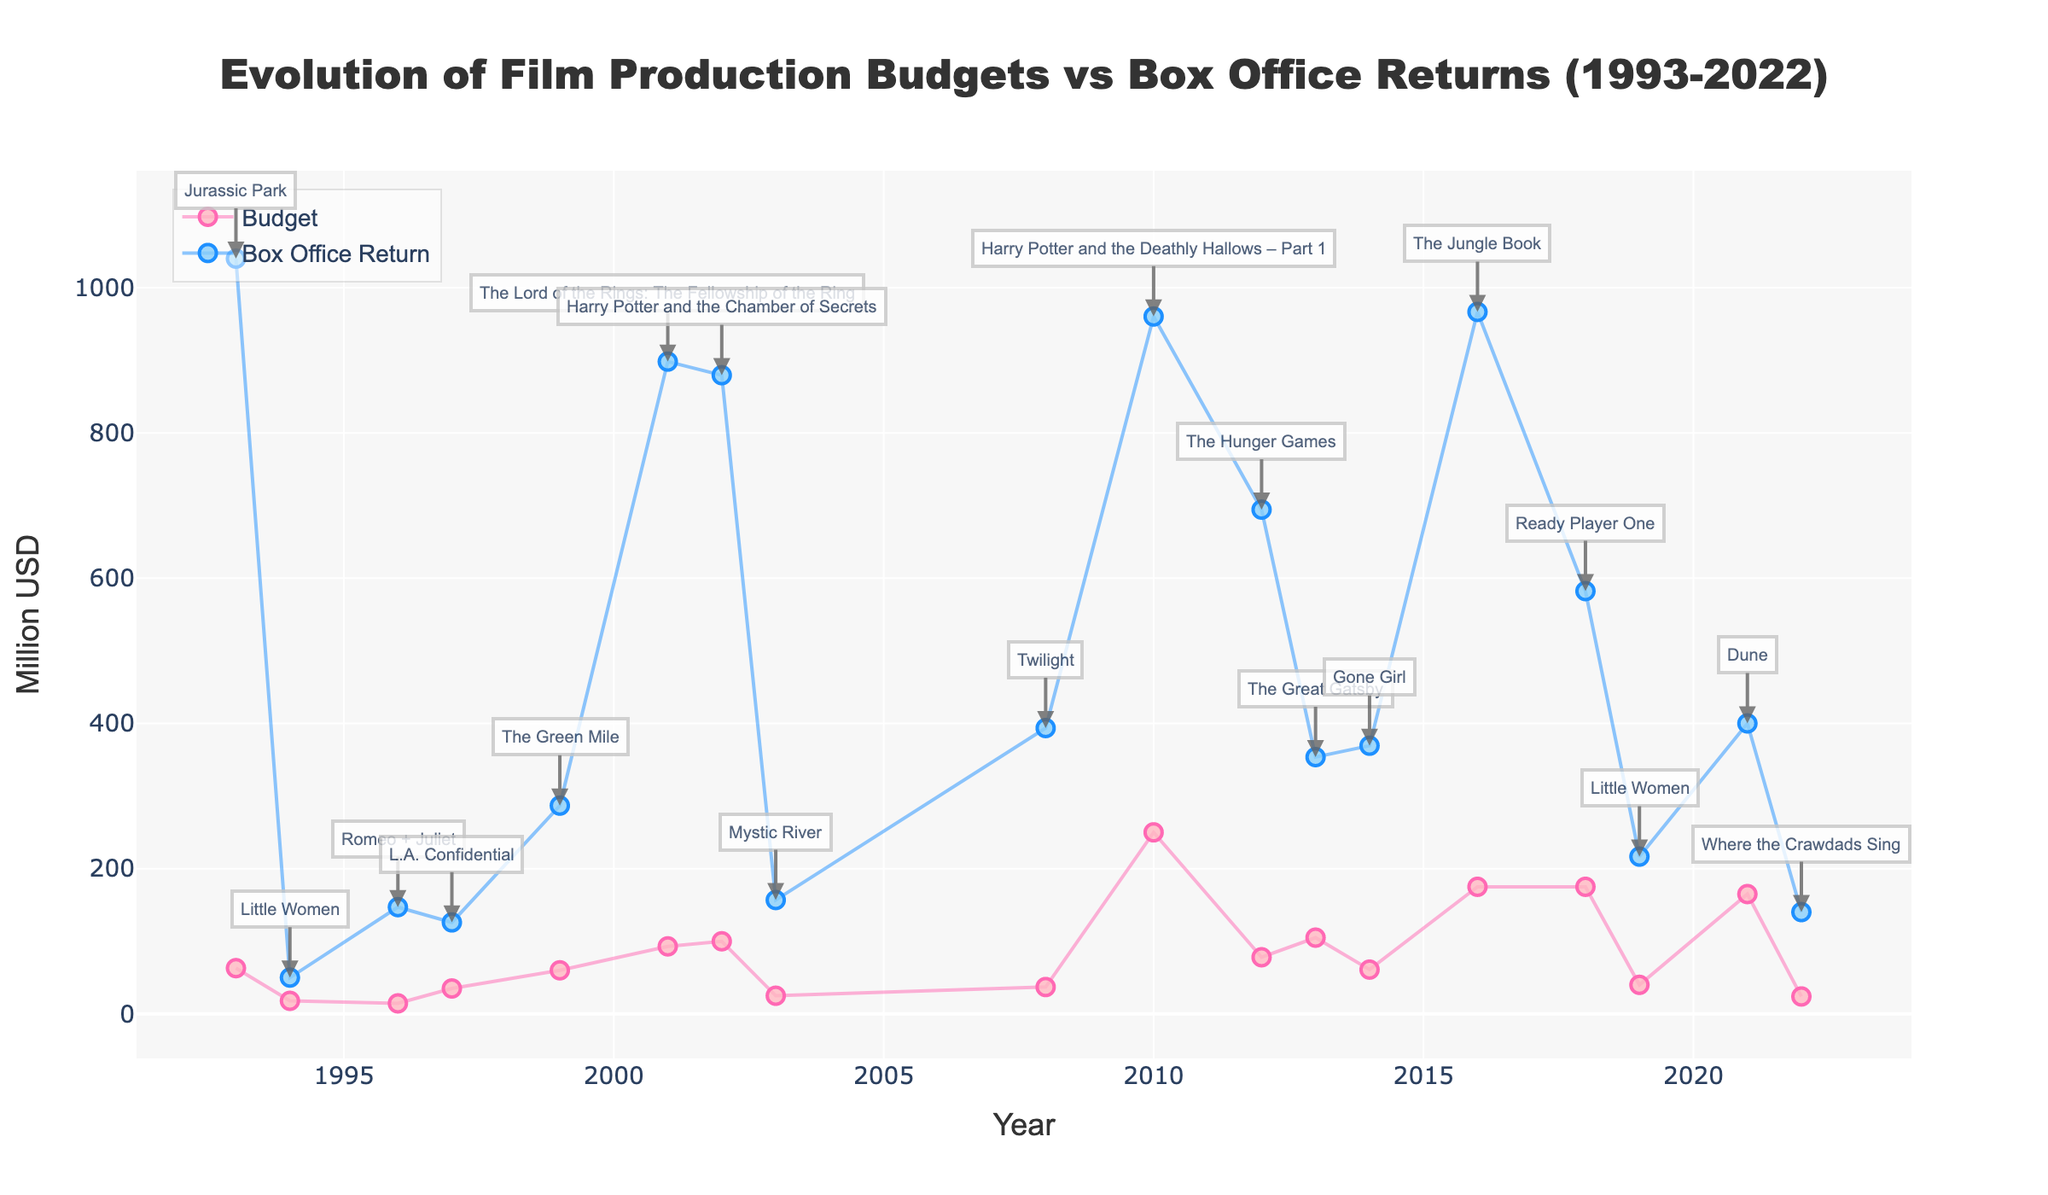What is the title of the figure? The title of the figure is displayed at the top center of the plot. Reading it reveals that the title is "Evolution of Film Production Budgets vs Box Office Returns (1993-2022)."
Answer: Evolution of Film Production Budgets vs Box Office Returns (1993-2022) What does the y-axis represent? By examining the y-axis label on the left side of the plot, it shows the term "Million USD," indicating that the y-axis represents monetary amounts in millions of dollars.
Answer: Million USD How many data points are there for the "Box Office Return"? By counting the number of markers on the "Box Office Return" line, we find there are as many markers as there are years listed in the dataset, which is 17.
Answer: 17 Which film had the highest box office return? Looking at the highest data point on the "Box Office Return" line and referring to the annotations, the film at this point is "Jurassic Park" in 1993 with a return of 1040 million USD.
Answer: Jurassic Park In what year did the highest budget occur, and which film was it for? Observing the peak value on the "Budget" line reveals the highest budget occurred in 2010 for the film "Harry Potter and the Deathly Hallows – Part 1" with a budget of 250 million USD.
Answer: 2010, Harry Potter and the Deathly Hallows – Part 1 What is the difference in budget between "The Jungle Book" (2016) and "Twilight" (2008)? The budget for "The Jungle Book" in 2016 is 175 million USD, and for "Twilight" in 2008, it is 37 million USD. By subtracting these two values, the difference is 175 - 37 = 138 million USD.
Answer: 138 million USD How did the average box office return change from the 1990s (1993-1999) to the 2000s (2000-2009)? First, find the average box office return for 1993-1999: (1040+50+147+126+286.8) / 5 = 329.56 million USD. Then, find the average for 2000-2009: (898.2+879.5+156.8+393.6) / 4 = 582.03 million USD. The change is 582.03 - 329.56 = 252.47 million USD.
Answer: Increased by 252.47 million USD Compare the box office return and budget of "The Great Gatsby" (2013). Which one is higher, and by how much? The budget for "The Great Gatsby" is 105 million USD, and its box office return is 353.6 million USD. The box office return is higher by 353.6 - 105 = 248.6 million USD.
Answer: Box office return, by 248.6 million USD Which year had the lowest budget, and what was the amount? By looking at the lowest point on the "Budget" line, the year is 1994 for the film "Little Women," with a budget of 18 million USD.
Answer: 1994, 18 million USD 